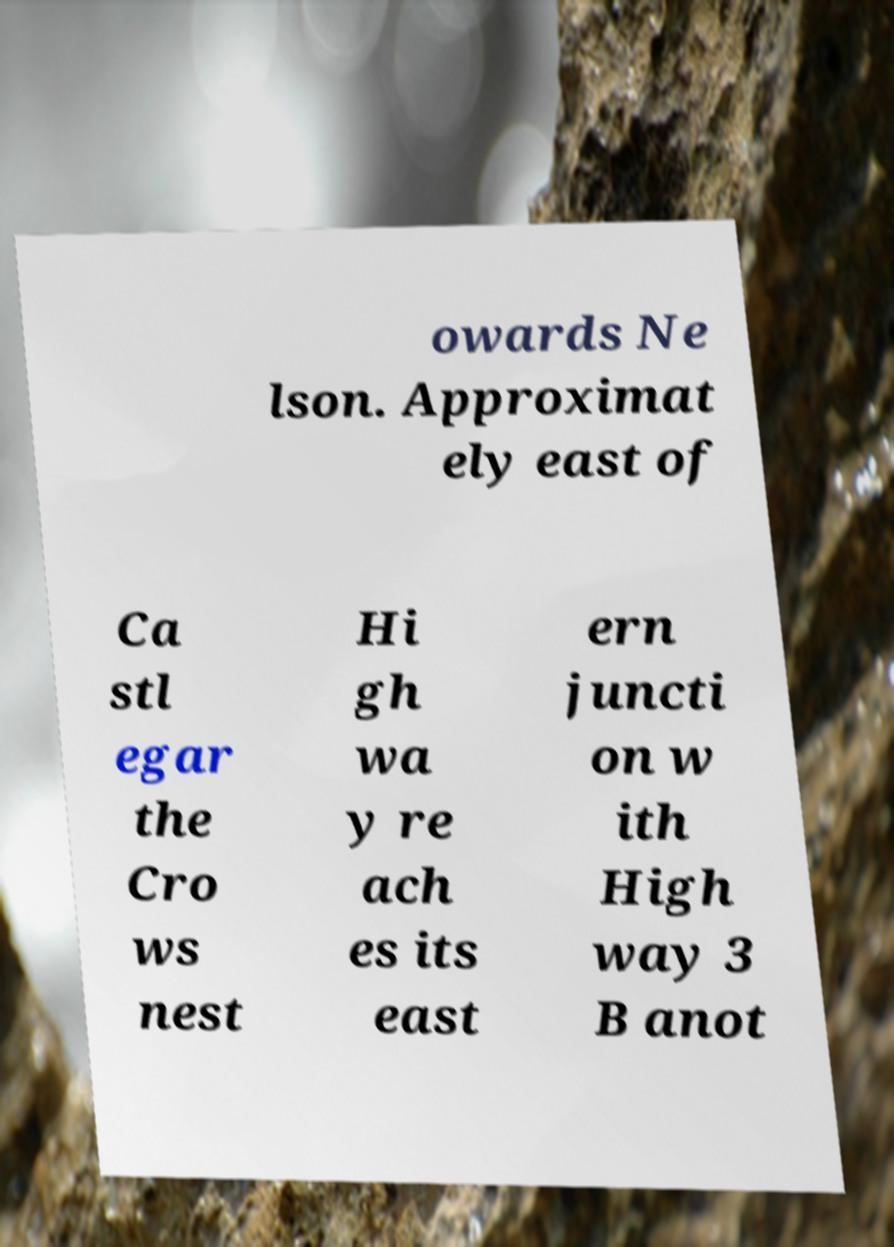Could you assist in decoding the text presented in this image and type it out clearly? owards Ne lson. Approximat ely east of Ca stl egar the Cro ws nest Hi gh wa y re ach es its east ern juncti on w ith High way 3 B anot 